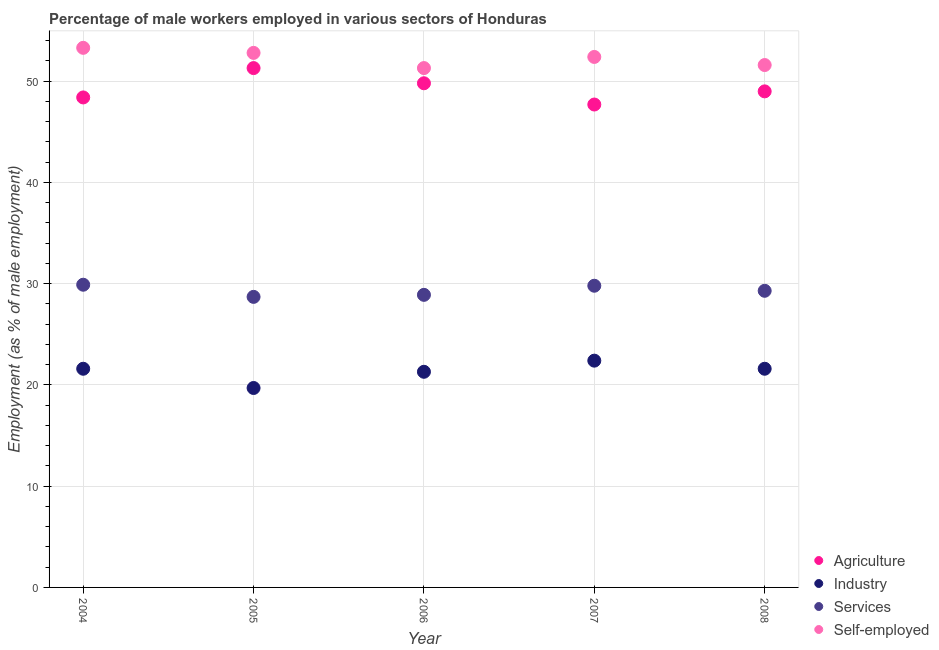How many different coloured dotlines are there?
Provide a short and direct response. 4. Is the number of dotlines equal to the number of legend labels?
Provide a succinct answer. Yes. What is the percentage of male workers in industry in 2006?
Offer a very short reply. 21.3. Across all years, what is the maximum percentage of male workers in industry?
Give a very brief answer. 22.4. Across all years, what is the minimum percentage of male workers in services?
Provide a succinct answer. 28.7. In which year was the percentage of male workers in agriculture maximum?
Your response must be concise. 2005. What is the total percentage of male workers in agriculture in the graph?
Your answer should be compact. 246.2. What is the difference between the percentage of male workers in agriculture in 2004 and that in 2005?
Ensure brevity in your answer.  -2.9. What is the difference between the percentage of male workers in industry in 2008 and the percentage of male workers in services in 2004?
Your answer should be very brief. -8.3. What is the average percentage of male workers in agriculture per year?
Provide a short and direct response. 49.24. In the year 2004, what is the difference between the percentage of male workers in services and percentage of male workers in agriculture?
Provide a short and direct response. -18.5. In how many years, is the percentage of male workers in services greater than 6 %?
Keep it short and to the point. 5. What is the ratio of the percentage of self employed male workers in 2007 to that in 2008?
Your response must be concise. 1.02. What is the difference between the highest and the second highest percentage of male workers in industry?
Provide a succinct answer. 0.8. What is the difference between the highest and the lowest percentage of male workers in services?
Make the answer very short. 1.2. In how many years, is the percentage of male workers in industry greater than the average percentage of male workers in industry taken over all years?
Your answer should be compact. 3. Is the sum of the percentage of male workers in industry in 2004 and 2005 greater than the maximum percentage of male workers in services across all years?
Offer a very short reply. Yes. Is it the case that in every year, the sum of the percentage of male workers in agriculture and percentage of male workers in industry is greater than the percentage of male workers in services?
Keep it short and to the point. Yes. Does the percentage of male workers in services monotonically increase over the years?
Your answer should be compact. No. What is the difference between two consecutive major ticks on the Y-axis?
Offer a very short reply. 10. Are the values on the major ticks of Y-axis written in scientific E-notation?
Make the answer very short. No. Does the graph contain grids?
Your answer should be compact. Yes. How many legend labels are there?
Your answer should be compact. 4. How are the legend labels stacked?
Keep it short and to the point. Vertical. What is the title of the graph?
Offer a very short reply. Percentage of male workers employed in various sectors of Honduras. What is the label or title of the X-axis?
Offer a very short reply. Year. What is the label or title of the Y-axis?
Provide a succinct answer. Employment (as % of male employment). What is the Employment (as % of male employment) in Agriculture in 2004?
Offer a terse response. 48.4. What is the Employment (as % of male employment) in Industry in 2004?
Make the answer very short. 21.6. What is the Employment (as % of male employment) of Services in 2004?
Provide a short and direct response. 29.9. What is the Employment (as % of male employment) of Self-employed in 2004?
Make the answer very short. 53.3. What is the Employment (as % of male employment) of Agriculture in 2005?
Offer a very short reply. 51.3. What is the Employment (as % of male employment) of Industry in 2005?
Keep it short and to the point. 19.7. What is the Employment (as % of male employment) in Services in 2005?
Offer a terse response. 28.7. What is the Employment (as % of male employment) in Self-employed in 2005?
Provide a short and direct response. 52.8. What is the Employment (as % of male employment) in Agriculture in 2006?
Offer a terse response. 49.8. What is the Employment (as % of male employment) of Industry in 2006?
Offer a terse response. 21.3. What is the Employment (as % of male employment) of Services in 2006?
Offer a very short reply. 28.9. What is the Employment (as % of male employment) in Self-employed in 2006?
Make the answer very short. 51.3. What is the Employment (as % of male employment) in Agriculture in 2007?
Offer a very short reply. 47.7. What is the Employment (as % of male employment) in Industry in 2007?
Make the answer very short. 22.4. What is the Employment (as % of male employment) in Services in 2007?
Offer a very short reply. 29.8. What is the Employment (as % of male employment) in Self-employed in 2007?
Make the answer very short. 52.4. What is the Employment (as % of male employment) of Industry in 2008?
Give a very brief answer. 21.6. What is the Employment (as % of male employment) in Services in 2008?
Provide a succinct answer. 29.3. What is the Employment (as % of male employment) of Self-employed in 2008?
Offer a very short reply. 51.6. Across all years, what is the maximum Employment (as % of male employment) of Agriculture?
Make the answer very short. 51.3. Across all years, what is the maximum Employment (as % of male employment) in Industry?
Make the answer very short. 22.4. Across all years, what is the maximum Employment (as % of male employment) of Services?
Provide a short and direct response. 29.9. Across all years, what is the maximum Employment (as % of male employment) of Self-employed?
Keep it short and to the point. 53.3. Across all years, what is the minimum Employment (as % of male employment) of Agriculture?
Your answer should be compact. 47.7. Across all years, what is the minimum Employment (as % of male employment) of Industry?
Provide a short and direct response. 19.7. Across all years, what is the minimum Employment (as % of male employment) in Services?
Your answer should be compact. 28.7. Across all years, what is the minimum Employment (as % of male employment) in Self-employed?
Ensure brevity in your answer.  51.3. What is the total Employment (as % of male employment) in Agriculture in the graph?
Give a very brief answer. 246.2. What is the total Employment (as % of male employment) of Industry in the graph?
Your answer should be compact. 106.6. What is the total Employment (as % of male employment) of Services in the graph?
Offer a very short reply. 146.6. What is the total Employment (as % of male employment) in Self-employed in the graph?
Your answer should be very brief. 261.4. What is the difference between the Employment (as % of male employment) of Agriculture in 2004 and that in 2005?
Ensure brevity in your answer.  -2.9. What is the difference between the Employment (as % of male employment) of Industry in 2004 and that in 2005?
Keep it short and to the point. 1.9. What is the difference between the Employment (as % of male employment) in Self-employed in 2004 and that in 2005?
Make the answer very short. 0.5. What is the difference between the Employment (as % of male employment) of Agriculture in 2004 and that in 2006?
Keep it short and to the point. -1.4. What is the difference between the Employment (as % of male employment) of Industry in 2004 and that in 2006?
Ensure brevity in your answer.  0.3. What is the difference between the Employment (as % of male employment) of Services in 2004 and that in 2006?
Your answer should be very brief. 1. What is the difference between the Employment (as % of male employment) of Self-employed in 2004 and that in 2006?
Your answer should be compact. 2. What is the difference between the Employment (as % of male employment) in Agriculture in 2004 and that in 2007?
Your answer should be very brief. 0.7. What is the difference between the Employment (as % of male employment) of Industry in 2004 and that in 2008?
Your response must be concise. 0. What is the difference between the Employment (as % of male employment) in Agriculture in 2005 and that in 2006?
Give a very brief answer. 1.5. What is the difference between the Employment (as % of male employment) of Services in 2005 and that in 2006?
Provide a succinct answer. -0.2. What is the difference between the Employment (as % of male employment) of Self-employed in 2005 and that in 2006?
Provide a succinct answer. 1.5. What is the difference between the Employment (as % of male employment) in Agriculture in 2005 and that in 2007?
Provide a short and direct response. 3.6. What is the difference between the Employment (as % of male employment) of Services in 2005 and that in 2007?
Provide a short and direct response. -1.1. What is the difference between the Employment (as % of male employment) of Services in 2005 and that in 2008?
Keep it short and to the point. -0.6. What is the difference between the Employment (as % of male employment) of Self-employed in 2006 and that in 2007?
Offer a very short reply. -1.1. What is the difference between the Employment (as % of male employment) in Self-employed in 2006 and that in 2008?
Ensure brevity in your answer.  -0.3. What is the difference between the Employment (as % of male employment) of Agriculture in 2007 and that in 2008?
Your answer should be very brief. -1.3. What is the difference between the Employment (as % of male employment) in Self-employed in 2007 and that in 2008?
Provide a short and direct response. 0.8. What is the difference between the Employment (as % of male employment) of Agriculture in 2004 and the Employment (as % of male employment) of Industry in 2005?
Offer a very short reply. 28.7. What is the difference between the Employment (as % of male employment) of Agriculture in 2004 and the Employment (as % of male employment) of Services in 2005?
Provide a short and direct response. 19.7. What is the difference between the Employment (as % of male employment) of Agriculture in 2004 and the Employment (as % of male employment) of Self-employed in 2005?
Give a very brief answer. -4.4. What is the difference between the Employment (as % of male employment) of Industry in 2004 and the Employment (as % of male employment) of Services in 2005?
Your answer should be very brief. -7.1. What is the difference between the Employment (as % of male employment) of Industry in 2004 and the Employment (as % of male employment) of Self-employed in 2005?
Give a very brief answer. -31.2. What is the difference between the Employment (as % of male employment) in Services in 2004 and the Employment (as % of male employment) in Self-employed in 2005?
Provide a succinct answer. -22.9. What is the difference between the Employment (as % of male employment) of Agriculture in 2004 and the Employment (as % of male employment) of Industry in 2006?
Keep it short and to the point. 27.1. What is the difference between the Employment (as % of male employment) in Agriculture in 2004 and the Employment (as % of male employment) in Services in 2006?
Your response must be concise. 19.5. What is the difference between the Employment (as % of male employment) in Agriculture in 2004 and the Employment (as % of male employment) in Self-employed in 2006?
Your answer should be compact. -2.9. What is the difference between the Employment (as % of male employment) of Industry in 2004 and the Employment (as % of male employment) of Self-employed in 2006?
Provide a short and direct response. -29.7. What is the difference between the Employment (as % of male employment) of Services in 2004 and the Employment (as % of male employment) of Self-employed in 2006?
Your answer should be very brief. -21.4. What is the difference between the Employment (as % of male employment) in Agriculture in 2004 and the Employment (as % of male employment) in Self-employed in 2007?
Offer a terse response. -4. What is the difference between the Employment (as % of male employment) in Industry in 2004 and the Employment (as % of male employment) in Services in 2007?
Offer a terse response. -8.2. What is the difference between the Employment (as % of male employment) in Industry in 2004 and the Employment (as % of male employment) in Self-employed in 2007?
Offer a very short reply. -30.8. What is the difference between the Employment (as % of male employment) of Services in 2004 and the Employment (as % of male employment) of Self-employed in 2007?
Ensure brevity in your answer.  -22.5. What is the difference between the Employment (as % of male employment) in Agriculture in 2004 and the Employment (as % of male employment) in Industry in 2008?
Provide a succinct answer. 26.8. What is the difference between the Employment (as % of male employment) of Industry in 2004 and the Employment (as % of male employment) of Services in 2008?
Make the answer very short. -7.7. What is the difference between the Employment (as % of male employment) of Industry in 2004 and the Employment (as % of male employment) of Self-employed in 2008?
Keep it short and to the point. -30. What is the difference between the Employment (as % of male employment) of Services in 2004 and the Employment (as % of male employment) of Self-employed in 2008?
Ensure brevity in your answer.  -21.7. What is the difference between the Employment (as % of male employment) of Agriculture in 2005 and the Employment (as % of male employment) of Services in 2006?
Ensure brevity in your answer.  22.4. What is the difference between the Employment (as % of male employment) in Agriculture in 2005 and the Employment (as % of male employment) in Self-employed in 2006?
Provide a short and direct response. 0. What is the difference between the Employment (as % of male employment) in Industry in 2005 and the Employment (as % of male employment) in Services in 2006?
Offer a very short reply. -9.2. What is the difference between the Employment (as % of male employment) in Industry in 2005 and the Employment (as % of male employment) in Self-employed in 2006?
Your answer should be very brief. -31.6. What is the difference between the Employment (as % of male employment) in Services in 2005 and the Employment (as % of male employment) in Self-employed in 2006?
Offer a terse response. -22.6. What is the difference between the Employment (as % of male employment) in Agriculture in 2005 and the Employment (as % of male employment) in Industry in 2007?
Your answer should be very brief. 28.9. What is the difference between the Employment (as % of male employment) of Agriculture in 2005 and the Employment (as % of male employment) of Services in 2007?
Give a very brief answer. 21.5. What is the difference between the Employment (as % of male employment) of Agriculture in 2005 and the Employment (as % of male employment) of Self-employed in 2007?
Offer a terse response. -1.1. What is the difference between the Employment (as % of male employment) of Industry in 2005 and the Employment (as % of male employment) of Services in 2007?
Provide a succinct answer. -10.1. What is the difference between the Employment (as % of male employment) in Industry in 2005 and the Employment (as % of male employment) in Self-employed in 2007?
Keep it short and to the point. -32.7. What is the difference between the Employment (as % of male employment) of Services in 2005 and the Employment (as % of male employment) of Self-employed in 2007?
Provide a succinct answer. -23.7. What is the difference between the Employment (as % of male employment) of Agriculture in 2005 and the Employment (as % of male employment) of Industry in 2008?
Provide a succinct answer. 29.7. What is the difference between the Employment (as % of male employment) in Agriculture in 2005 and the Employment (as % of male employment) in Self-employed in 2008?
Give a very brief answer. -0.3. What is the difference between the Employment (as % of male employment) of Industry in 2005 and the Employment (as % of male employment) of Self-employed in 2008?
Ensure brevity in your answer.  -31.9. What is the difference between the Employment (as % of male employment) of Services in 2005 and the Employment (as % of male employment) of Self-employed in 2008?
Make the answer very short. -22.9. What is the difference between the Employment (as % of male employment) of Agriculture in 2006 and the Employment (as % of male employment) of Industry in 2007?
Offer a very short reply. 27.4. What is the difference between the Employment (as % of male employment) in Industry in 2006 and the Employment (as % of male employment) in Self-employed in 2007?
Provide a succinct answer. -31.1. What is the difference between the Employment (as % of male employment) in Services in 2006 and the Employment (as % of male employment) in Self-employed in 2007?
Provide a succinct answer. -23.5. What is the difference between the Employment (as % of male employment) in Agriculture in 2006 and the Employment (as % of male employment) in Industry in 2008?
Provide a succinct answer. 28.2. What is the difference between the Employment (as % of male employment) in Agriculture in 2006 and the Employment (as % of male employment) in Self-employed in 2008?
Give a very brief answer. -1.8. What is the difference between the Employment (as % of male employment) of Industry in 2006 and the Employment (as % of male employment) of Services in 2008?
Offer a very short reply. -8. What is the difference between the Employment (as % of male employment) of Industry in 2006 and the Employment (as % of male employment) of Self-employed in 2008?
Keep it short and to the point. -30.3. What is the difference between the Employment (as % of male employment) of Services in 2006 and the Employment (as % of male employment) of Self-employed in 2008?
Make the answer very short. -22.7. What is the difference between the Employment (as % of male employment) in Agriculture in 2007 and the Employment (as % of male employment) in Industry in 2008?
Make the answer very short. 26.1. What is the difference between the Employment (as % of male employment) of Agriculture in 2007 and the Employment (as % of male employment) of Services in 2008?
Keep it short and to the point. 18.4. What is the difference between the Employment (as % of male employment) in Agriculture in 2007 and the Employment (as % of male employment) in Self-employed in 2008?
Offer a terse response. -3.9. What is the difference between the Employment (as % of male employment) in Industry in 2007 and the Employment (as % of male employment) in Self-employed in 2008?
Keep it short and to the point. -29.2. What is the difference between the Employment (as % of male employment) of Services in 2007 and the Employment (as % of male employment) of Self-employed in 2008?
Offer a terse response. -21.8. What is the average Employment (as % of male employment) of Agriculture per year?
Give a very brief answer. 49.24. What is the average Employment (as % of male employment) of Industry per year?
Make the answer very short. 21.32. What is the average Employment (as % of male employment) of Services per year?
Give a very brief answer. 29.32. What is the average Employment (as % of male employment) of Self-employed per year?
Provide a succinct answer. 52.28. In the year 2004, what is the difference between the Employment (as % of male employment) in Agriculture and Employment (as % of male employment) in Industry?
Ensure brevity in your answer.  26.8. In the year 2004, what is the difference between the Employment (as % of male employment) of Agriculture and Employment (as % of male employment) of Services?
Offer a terse response. 18.5. In the year 2004, what is the difference between the Employment (as % of male employment) of Agriculture and Employment (as % of male employment) of Self-employed?
Ensure brevity in your answer.  -4.9. In the year 2004, what is the difference between the Employment (as % of male employment) in Industry and Employment (as % of male employment) in Services?
Offer a terse response. -8.3. In the year 2004, what is the difference between the Employment (as % of male employment) in Industry and Employment (as % of male employment) in Self-employed?
Offer a very short reply. -31.7. In the year 2004, what is the difference between the Employment (as % of male employment) in Services and Employment (as % of male employment) in Self-employed?
Provide a short and direct response. -23.4. In the year 2005, what is the difference between the Employment (as % of male employment) in Agriculture and Employment (as % of male employment) in Industry?
Your answer should be very brief. 31.6. In the year 2005, what is the difference between the Employment (as % of male employment) in Agriculture and Employment (as % of male employment) in Services?
Keep it short and to the point. 22.6. In the year 2005, what is the difference between the Employment (as % of male employment) of Agriculture and Employment (as % of male employment) of Self-employed?
Keep it short and to the point. -1.5. In the year 2005, what is the difference between the Employment (as % of male employment) in Industry and Employment (as % of male employment) in Services?
Offer a very short reply. -9. In the year 2005, what is the difference between the Employment (as % of male employment) of Industry and Employment (as % of male employment) of Self-employed?
Make the answer very short. -33.1. In the year 2005, what is the difference between the Employment (as % of male employment) of Services and Employment (as % of male employment) of Self-employed?
Provide a succinct answer. -24.1. In the year 2006, what is the difference between the Employment (as % of male employment) of Agriculture and Employment (as % of male employment) of Industry?
Provide a short and direct response. 28.5. In the year 2006, what is the difference between the Employment (as % of male employment) in Agriculture and Employment (as % of male employment) in Services?
Offer a terse response. 20.9. In the year 2006, what is the difference between the Employment (as % of male employment) in Industry and Employment (as % of male employment) in Services?
Offer a terse response. -7.6. In the year 2006, what is the difference between the Employment (as % of male employment) of Services and Employment (as % of male employment) of Self-employed?
Offer a terse response. -22.4. In the year 2007, what is the difference between the Employment (as % of male employment) of Agriculture and Employment (as % of male employment) of Industry?
Your response must be concise. 25.3. In the year 2007, what is the difference between the Employment (as % of male employment) of Agriculture and Employment (as % of male employment) of Services?
Your answer should be compact. 17.9. In the year 2007, what is the difference between the Employment (as % of male employment) of Agriculture and Employment (as % of male employment) of Self-employed?
Your answer should be compact. -4.7. In the year 2007, what is the difference between the Employment (as % of male employment) in Services and Employment (as % of male employment) in Self-employed?
Your response must be concise. -22.6. In the year 2008, what is the difference between the Employment (as % of male employment) in Agriculture and Employment (as % of male employment) in Industry?
Your answer should be very brief. 27.4. In the year 2008, what is the difference between the Employment (as % of male employment) in Industry and Employment (as % of male employment) in Services?
Ensure brevity in your answer.  -7.7. In the year 2008, what is the difference between the Employment (as % of male employment) in Industry and Employment (as % of male employment) in Self-employed?
Provide a succinct answer. -30. In the year 2008, what is the difference between the Employment (as % of male employment) in Services and Employment (as % of male employment) in Self-employed?
Offer a terse response. -22.3. What is the ratio of the Employment (as % of male employment) of Agriculture in 2004 to that in 2005?
Offer a terse response. 0.94. What is the ratio of the Employment (as % of male employment) in Industry in 2004 to that in 2005?
Offer a very short reply. 1.1. What is the ratio of the Employment (as % of male employment) of Services in 2004 to that in 2005?
Your answer should be very brief. 1.04. What is the ratio of the Employment (as % of male employment) of Self-employed in 2004 to that in 2005?
Your response must be concise. 1.01. What is the ratio of the Employment (as % of male employment) of Agriculture in 2004 to that in 2006?
Offer a terse response. 0.97. What is the ratio of the Employment (as % of male employment) of Industry in 2004 to that in 2006?
Give a very brief answer. 1.01. What is the ratio of the Employment (as % of male employment) of Services in 2004 to that in 2006?
Make the answer very short. 1.03. What is the ratio of the Employment (as % of male employment) of Self-employed in 2004 to that in 2006?
Provide a short and direct response. 1.04. What is the ratio of the Employment (as % of male employment) of Agriculture in 2004 to that in 2007?
Your response must be concise. 1.01. What is the ratio of the Employment (as % of male employment) of Services in 2004 to that in 2007?
Keep it short and to the point. 1. What is the ratio of the Employment (as % of male employment) of Self-employed in 2004 to that in 2007?
Provide a short and direct response. 1.02. What is the ratio of the Employment (as % of male employment) in Agriculture in 2004 to that in 2008?
Make the answer very short. 0.99. What is the ratio of the Employment (as % of male employment) in Services in 2004 to that in 2008?
Provide a succinct answer. 1.02. What is the ratio of the Employment (as % of male employment) in Self-employed in 2004 to that in 2008?
Offer a terse response. 1.03. What is the ratio of the Employment (as % of male employment) of Agriculture in 2005 to that in 2006?
Keep it short and to the point. 1.03. What is the ratio of the Employment (as % of male employment) of Industry in 2005 to that in 2006?
Your answer should be very brief. 0.92. What is the ratio of the Employment (as % of male employment) in Services in 2005 to that in 2006?
Give a very brief answer. 0.99. What is the ratio of the Employment (as % of male employment) in Self-employed in 2005 to that in 2006?
Offer a very short reply. 1.03. What is the ratio of the Employment (as % of male employment) of Agriculture in 2005 to that in 2007?
Your response must be concise. 1.08. What is the ratio of the Employment (as % of male employment) of Industry in 2005 to that in 2007?
Offer a very short reply. 0.88. What is the ratio of the Employment (as % of male employment) in Services in 2005 to that in 2007?
Offer a very short reply. 0.96. What is the ratio of the Employment (as % of male employment) of Self-employed in 2005 to that in 2007?
Offer a very short reply. 1.01. What is the ratio of the Employment (as % of male employment) of Agriculture in 2005 to that in 2008?
Keep it short and to the point. 1.05. What is the ratio of the Employment (as % of male employment) of Industry in 2005 to that in 2008?
Offer a terse response. 0.91. What is the ratio of the Employment (as % of male employment) in Services in 2005 to that in 2008?
Give a very brief answer. 0.98. What is the ratio of the Employment (as % of male employment) of Self-employed in 2005 to that in 2008?
Keep it short and to the point. 1.02. What is the ratio of the Employment (as % of male employment) in Agriculture in 2006 to that in 2007?
Your response must be concise. 1.04. What is the ratio of the Employment (as % of male employment) of Industry in 2006 to that in 2007?
Your answer should be compact. 0.95. What is the ratio of the Employment (as % of male employment) in Services in 2006 to that in 2007?
Your response must be concise. 0.97. What is the ratio of the Employment (as % of male employment) in Self-employed in 2006 to that in 2007?
Give a very brief answer. 0.98. What is the ratio of the Employment (as % of male employment) of Agriculture in 2006 to that in 2008?
Make the answer very short. 1.02. What is the ratio of the Employment (as % of male employment) in Industry in 2006 to that in 2008?
Your response must be concise. 0.99. What is the ratio of the Employment (as % of male employment) in Services in 2006 to that in 2008?
Your response must be concise. 0.99. What is the ratio of the Employment (as % of male employment) of Agriculture in 2007 to that in 2008?
Your answer should be very brief. 0.97. What is the ratio of the Employment (as % of male employment) of Services in 2007 to that in 2008?
Give a very brief answer. 1.02. What is the ratio of the Employment (as % of male employment) of Self-employed in 2007 to that in 2008?
Your response must be concise. 1.02. What is the difference between the highest and the second highest Employment (as % of male employment) of Agriculture?
Keep it short and to the point. 1.5. What is the difference between the highest and the second highest Employment (as % of male employment) of Industry?
Give a very brief answer. 0.8. What is the difference between the highest and the lowest Employment (as % of male employment) of Industry?
Keep it short and to the point. 2.7. What is the difference between the highest and the lowest Employment (as % of male employment) in Self-employed?
Your response must be concise. 2. 